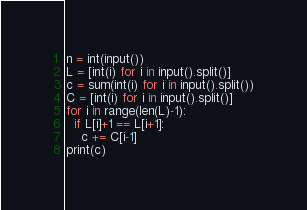<code> <loc_0><loc_0><loc_500><loc_500><_Python_>n = int(input())
L = [int(i) for i in input().split()]
c = sum(int(i) for i in input().split())
C = [int(i) for i in input().split()]
for i in range(len(L)-1):
  if L[i]+1 == L[i+1]:
    c += C[i-1]
print(c)</code> 